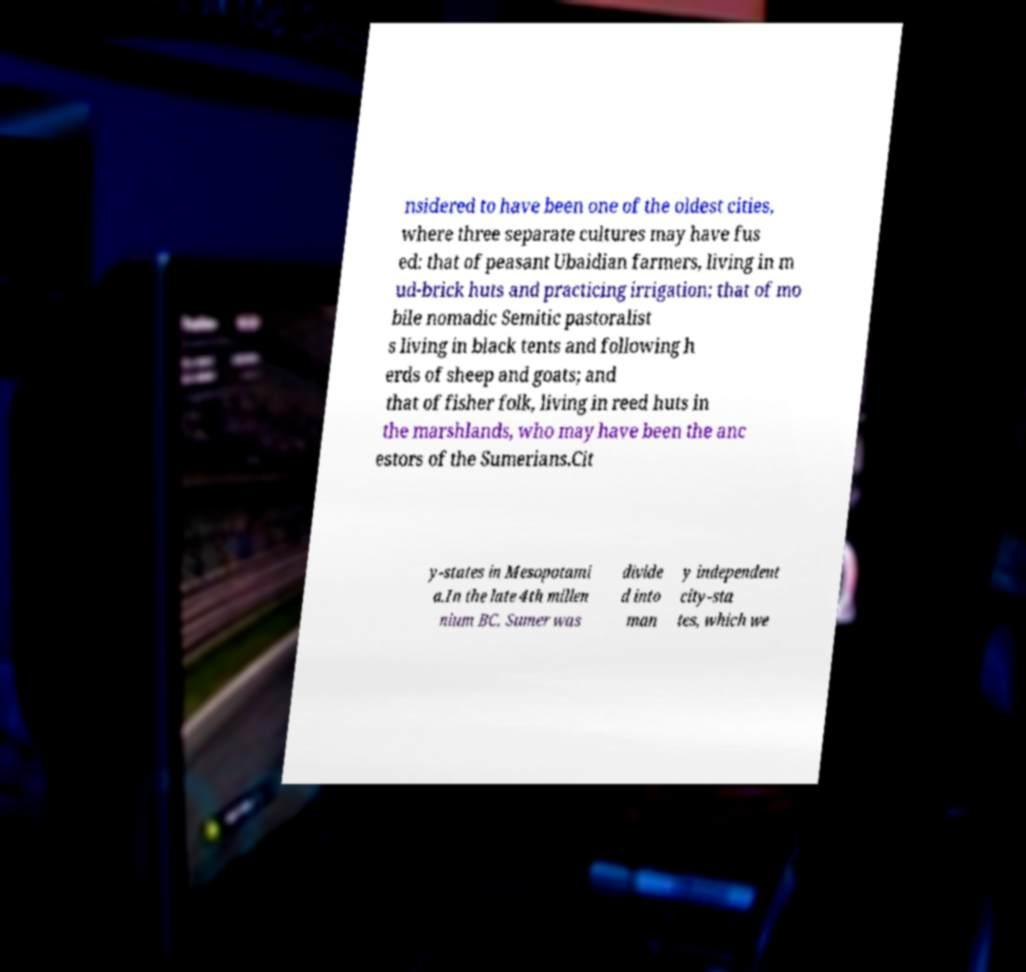Can you read and provide the text displayed in the image?This photo seems to have some interesting text. Can you extract and type it out for me? nsidered to have been one of the oldest cities, where three separate cultures may have fus ed: that of peasant Ubaidian farmers, living in m ud-brick huts and practicing irrigation; that of mo bile nomadic Semitic pastoralist s living in black tents and following h erds of sheep and goats; and that of fisher folk, living in reed huts in the marshlands, who may have been the anc estors of the Sumerians.Cit y-states in Mesopotami a.In the late 4th millen nium BC, Sumer was divide d into man y independent city-sta tes, which we 